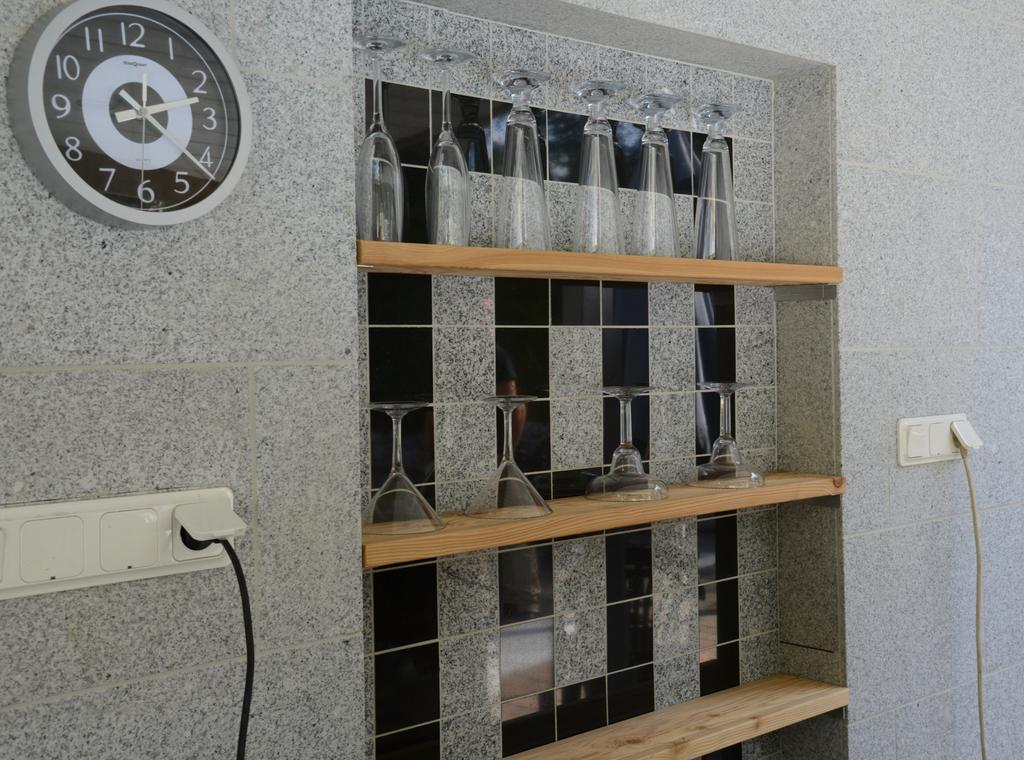Provide a one-sentence caption for the provided image. A clock on the wall by a shelf of glasses and the clock says MapQuest on it. 